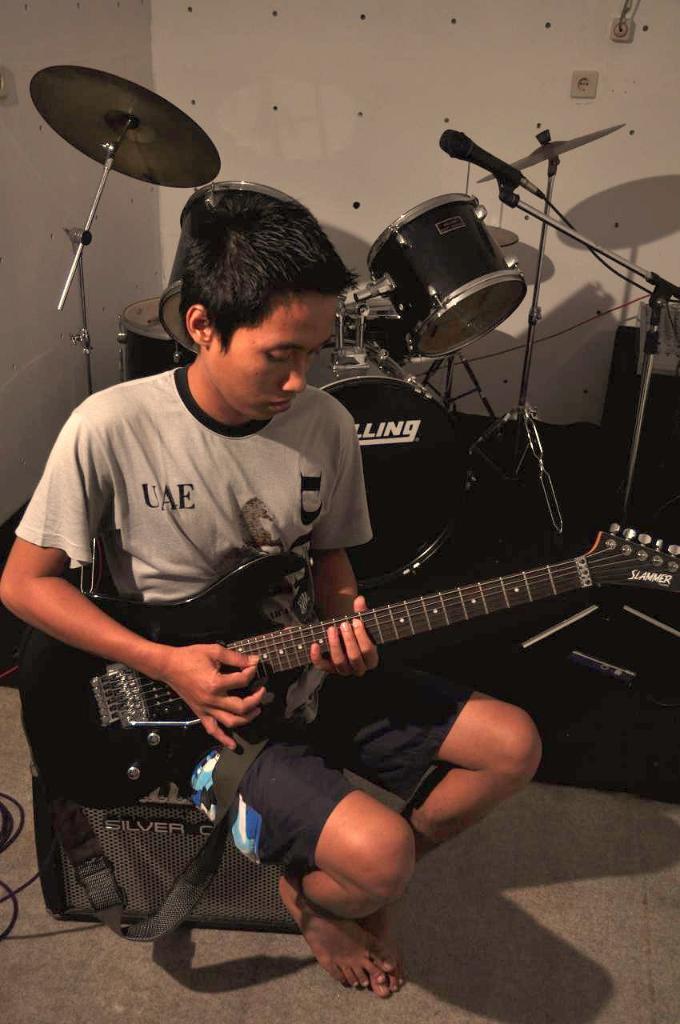Please provide a concise description of this image. In this image I can see a person wearing t shirt and black short is sitting and holding a guitar in his hand. I can see a bag on the floor and in the background I can see few musical instruments, a microphone and the wall. 